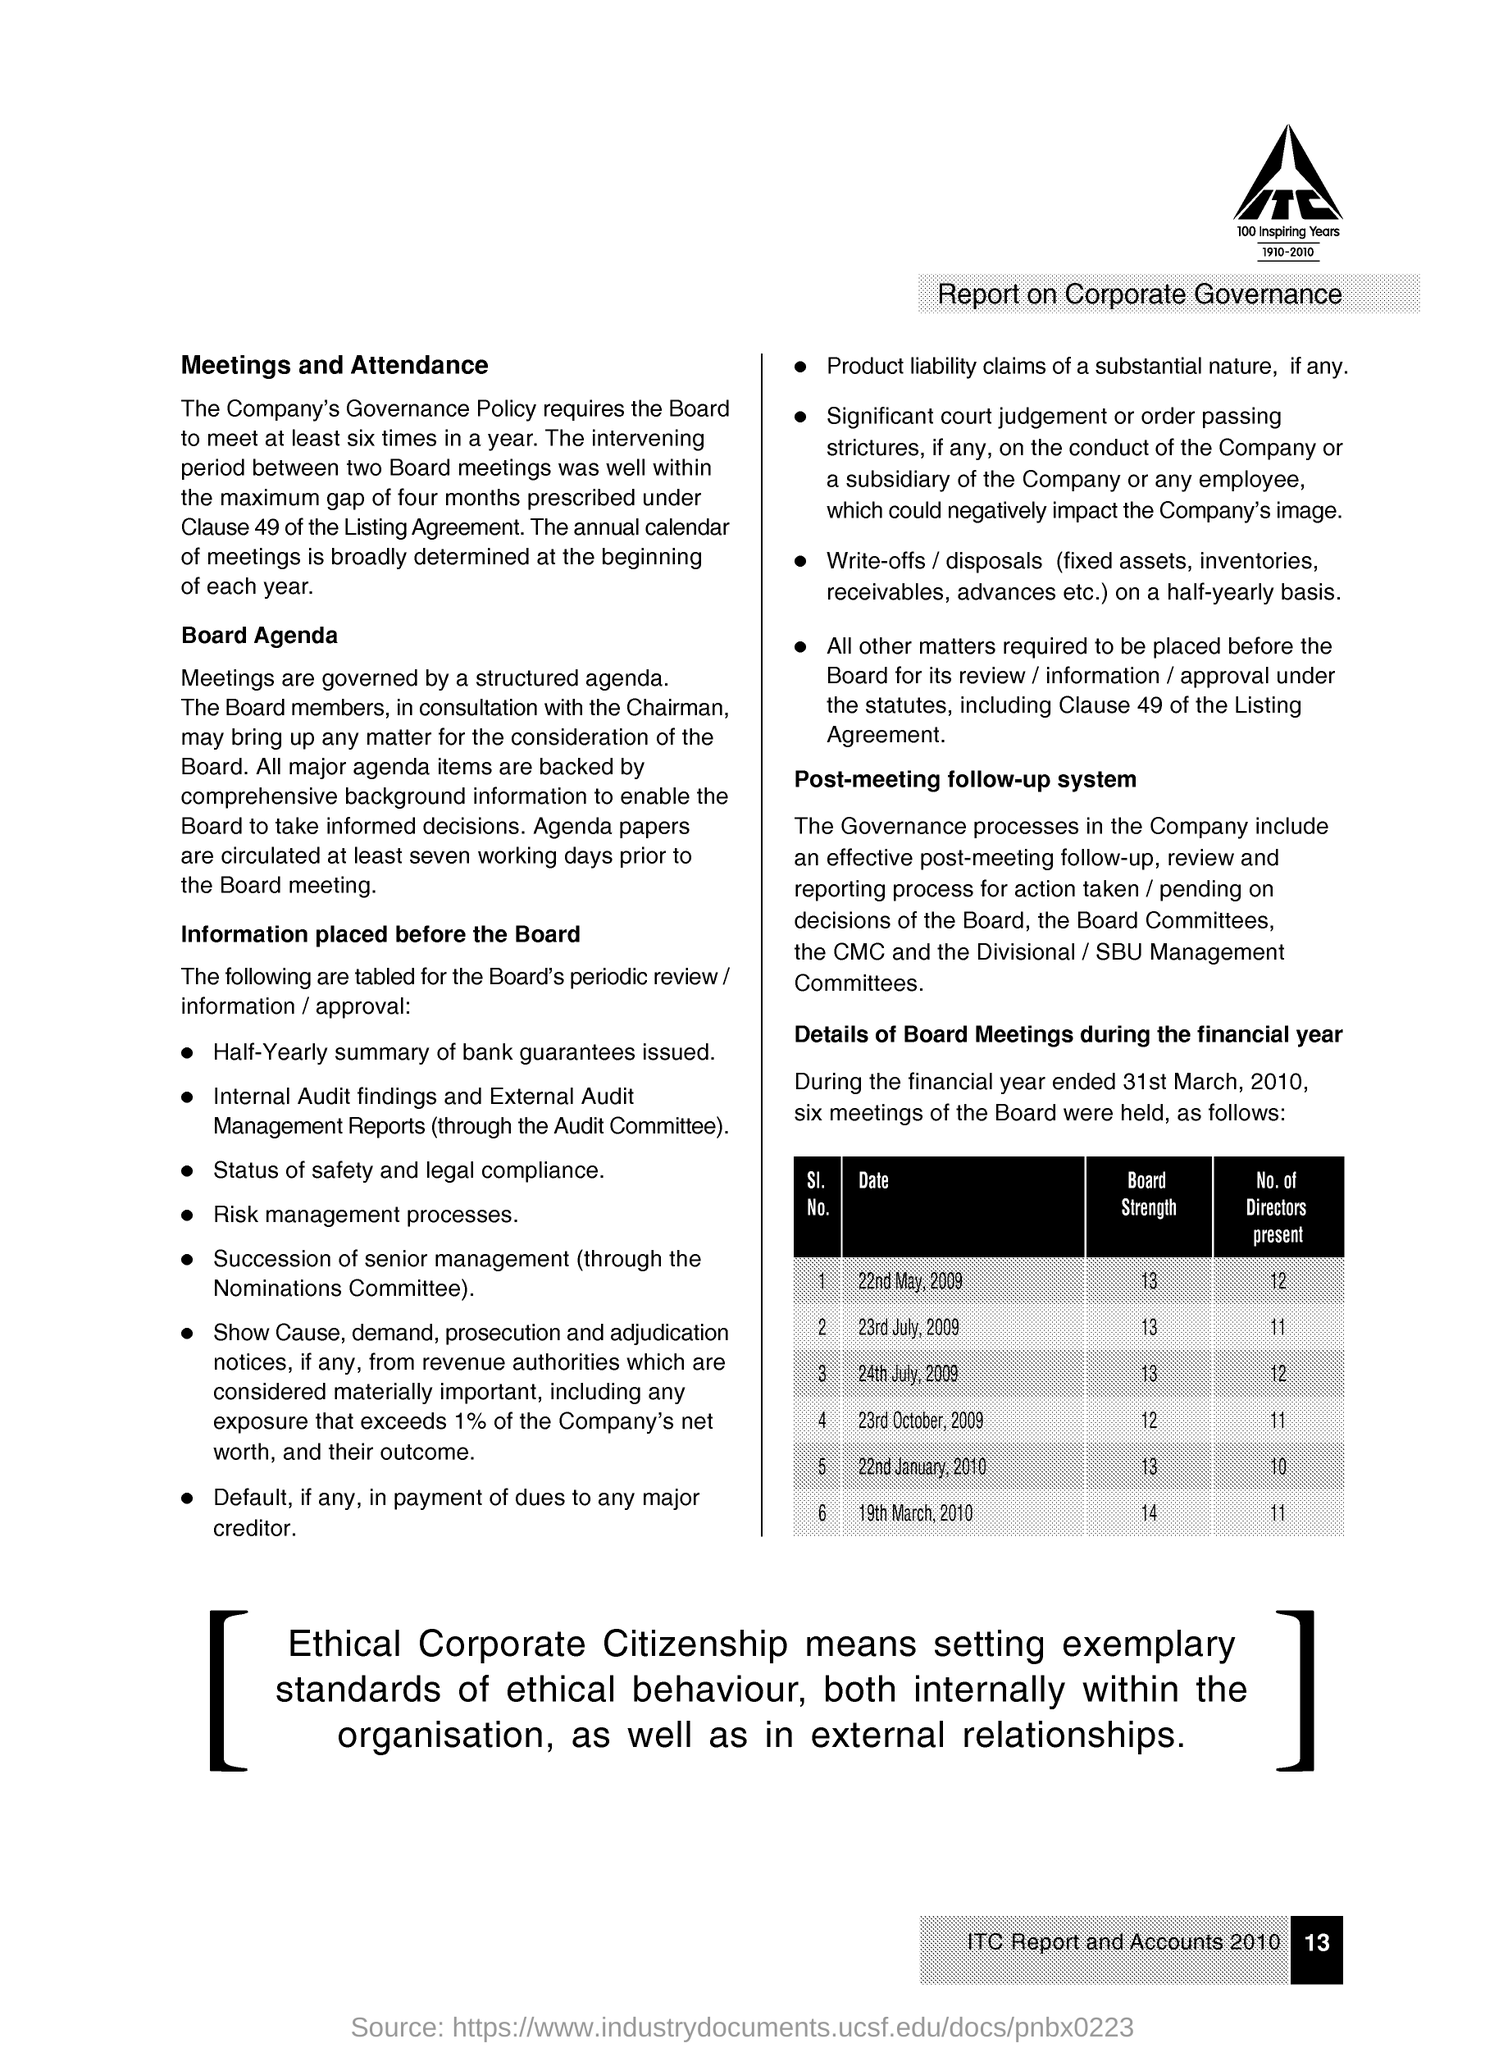Identify some key points in this picture. On January 22nd, 2010, there were 10 directors present. The page number is 13. The minimum number of directors present is 10. There were 12 members of the board of directors present at the meeting that took place on May 22nd, 2009. 